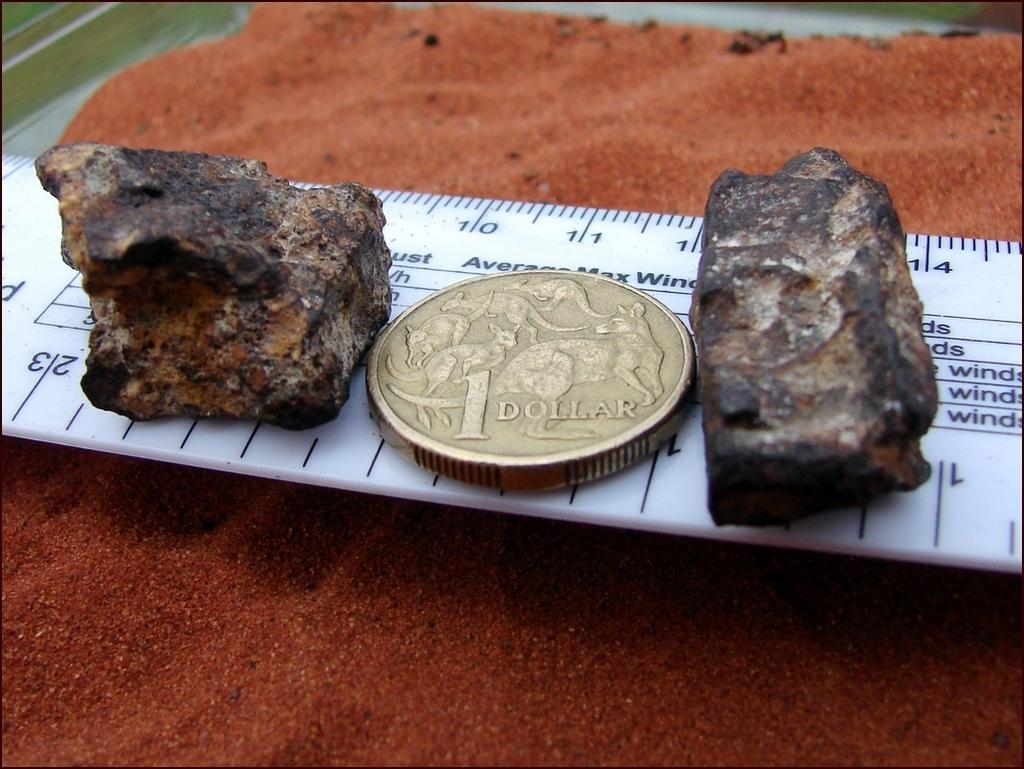What type of objects can be seen in the image? There are stones, coins, and sand in the image. What is used to weigh objects in the image? There is a scale in the image. What is the background of the image like? The background of the image is blurred. What type of grape is being used to measure the weight of the stones in the image? There is no grape present in the image, and grapes are not used for measuring weight. 